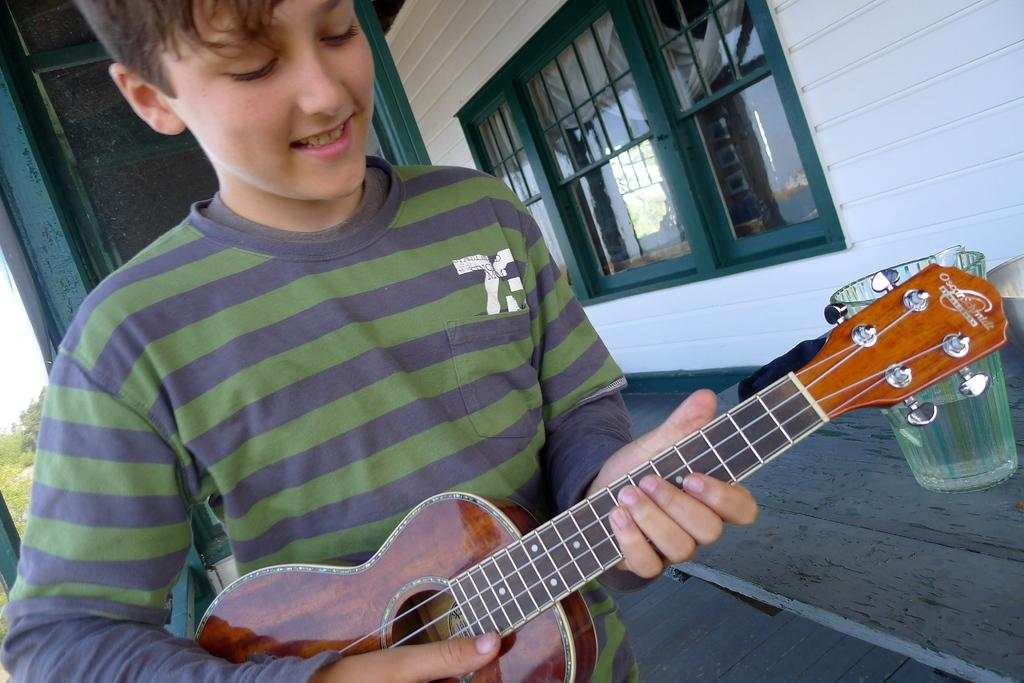Who is the main subject in the image? There is a boy in the image. What is the boy doing in the image? The boy is playing a guitar. What object is near the boy? There is a glass near the boy. What can be seen in the background of the image? There are trees in the background of the image. What is the boy's opinion on the ongoing discussion about the wall in the image? There is no discussion or wall present in the image, so it is not possible to determine the boy's opinion on the matter. 